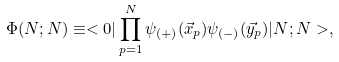<formula> <loc_0><loc_0><loc_500><loc_500>\Phi ( N ; N ) \equiv < 0 | \prod _ { p = 1 } ^ { N } \psi _ { ( + ) } ( \vec { x } _ { p } ) \psi _ { ( - ) } ( \vec { y } _ { p } ) | N ; N > ,</formula> 